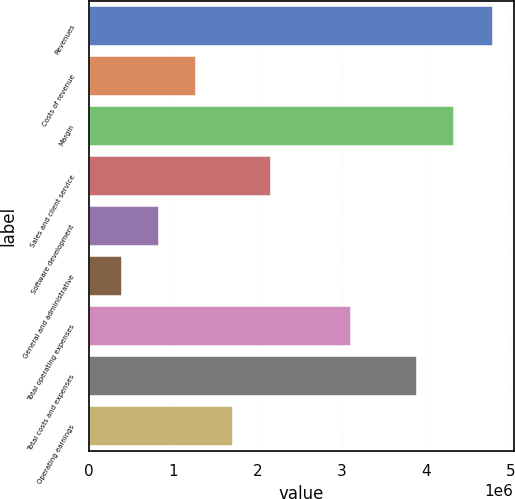Convert chart to OTSL. <chart><loc_0><loc_0><loc_500><loc_500><bar_chart><fcel>Revenues<fcel>Costs of revenue<fcel>Margin<fcel>Sales and client service<fcel>Software development<fcel>General and administrative<fcel>Total operating expenses<fcel>Total costs and expenses<fcel>Operating earnings<nl><fcel>4.79647e+06<fcel>1.27326e+06<fcel>4.32586e+06<fcel>2.15406e+06<fcel>832856<fcel>392454<fcel>3.10634e+06<fcel>3.88546e+06<fcel>1.71366e+06<nl></chart> 